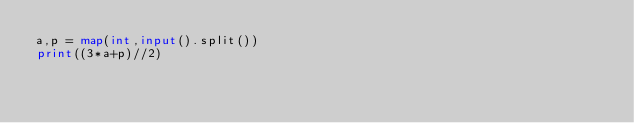Convert code to text. <code><loc_0><loc_0><loc_500><loc_500><_Python_>a,p = map(int,input().split())
print((3*a+p)//2)</code> 